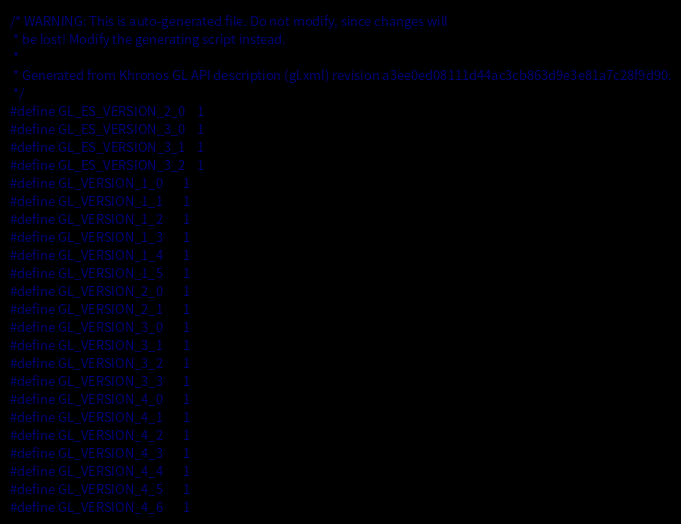<code> <loc_0><loc_0><loc_500><loc_500><_C++_>/* WARNING: This is auto-generated file. Do not modify, since changes will
 * be lost! Modify the generating script instead.
 *
 * Generated from Khronos GL API description (gl.xml) revision a3ee0ed08111d44ac3cb863d9e3e81a7c28f9d90.
 */
#define GL_ES_VERSION_2_0	1
#define GL_ES_VERSION_3_0	1
#define GL_ES_VERSION_3_1	1
#define GL_ES_VERSION_3_2	1
#define GL_VERSION_1_0		1
#define GL_VERSION_1_1		1
#define GL_VERSION_1_2		1
#define GL_VERSION_1_3		1
#define GL_VERSION_1_4		1
#define GL_VERSION_1_5		1
#define GL_VERSION_2_0		1
#define GL_VERSION_2_1		1
#define GL_VERSION_3_0		1
#define GL_VERSION_3_1		1
#define GL_VERSION_3_2		1
#define GL_VERSION_3_3		1
#define GL_VERSION_4_0		1
#define GL_VERSION_4_1		1
#define GL_VERSION_4_2		1
#define GL_VERSION_4_3		1
#define GL_VERSION_4_4		1
#define GL_VERSION_4_5		1
#define GL_VERSION_4_6		1
</code> 